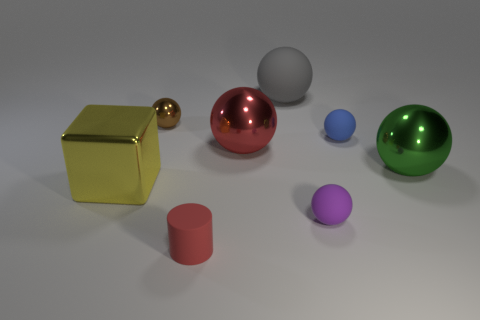Do the red object that is to the right of the red cylinder and the tiny red cylinder have the same size?
Make the answer very short. No. Is there a thing that has the same color as the matte cylinder?
Keep it short and to the point. Yes. Are there any big shiny spheres to the right of the metal object to the left of the tiny shiny sphere?
Offer a very short reply. Yes. Is there a blue ball that has the same material as the big gray thing?
Provide a short and direct response. Yes. There is a object on the left side of the metal ball to the left of the small red cylinder; what is its material?
Offer a very short reply. Metal. The tiny thing that is left of the tiny purple matte object and behind the yellow metallic thing is made of what material?
Offer a terse response. Metal. Are there the same number of metal balls left of the yellow cube and big brown metal objects?
Make the answer very short. Yes. How many tiny blue rubber things have the same shape as the yellow object?
Give a very brief answer. 0. What size is the shiny sphere left of the object that is in front of the sphere in front of the yellow object?
Give a very brief answer. Small. Does the large sphere that is on the right side of the blue thing have the same material as the tiny blue sphere?
Ensure brevity in your answer.  No. 